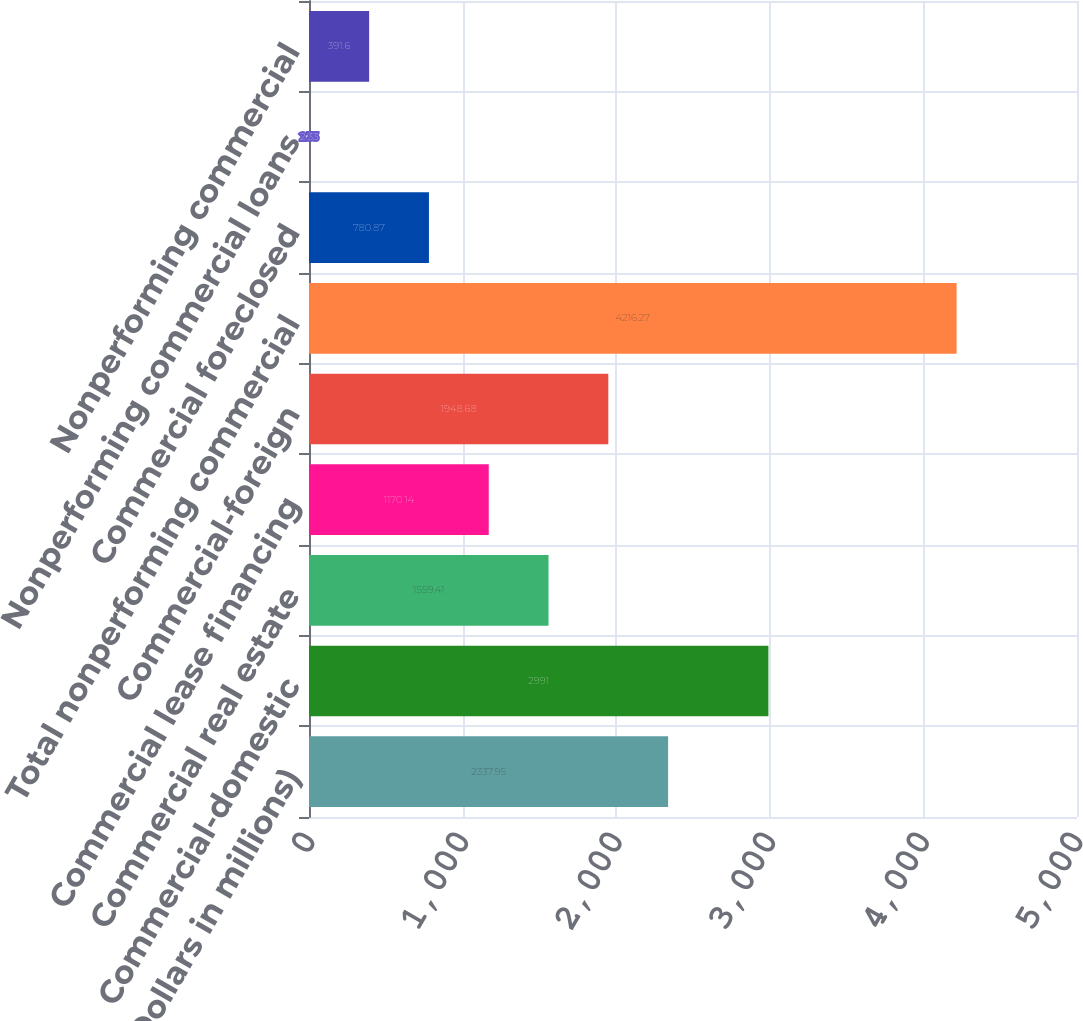Convert chart to OTSL. <chart><loc_0><loc_0><loc_500><loc_500><bar_chart><fcel>(Dollars in millions)<fcel>Commercial-domestic<fcel>Commercial real estate<fcel>Commercial lease financing<fcel>Commercial-foreign<fcel>Total nonperforming commercial<fcel>Commercial foreclosed<fcel>Nonperforming commercial loans<fcel>Nonperforming commercial<nl><fcel>2337.95<fcel>2991<fcel>1559.41<fcel>1170.14<fcel>1948.68<fcel>4216.27<fcel>780.87<fcel>2.33<fcel>391.6<nl></chart> 